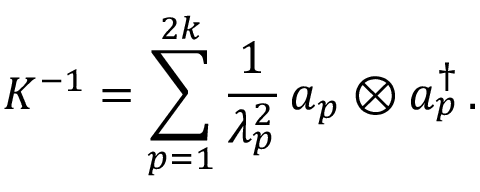Convert formula to latex. <formula><loc_0><loc_0><loc_500><loc_500>K ^ { - 1 } = \sum _ { p = 1 } ^ { 2 k } { \frac { 1 } { \lambda _ { p } ^ { 2 } } } \, a _ { p } \otimes a _ { p } ^ { \dagger } \, .</formula> 